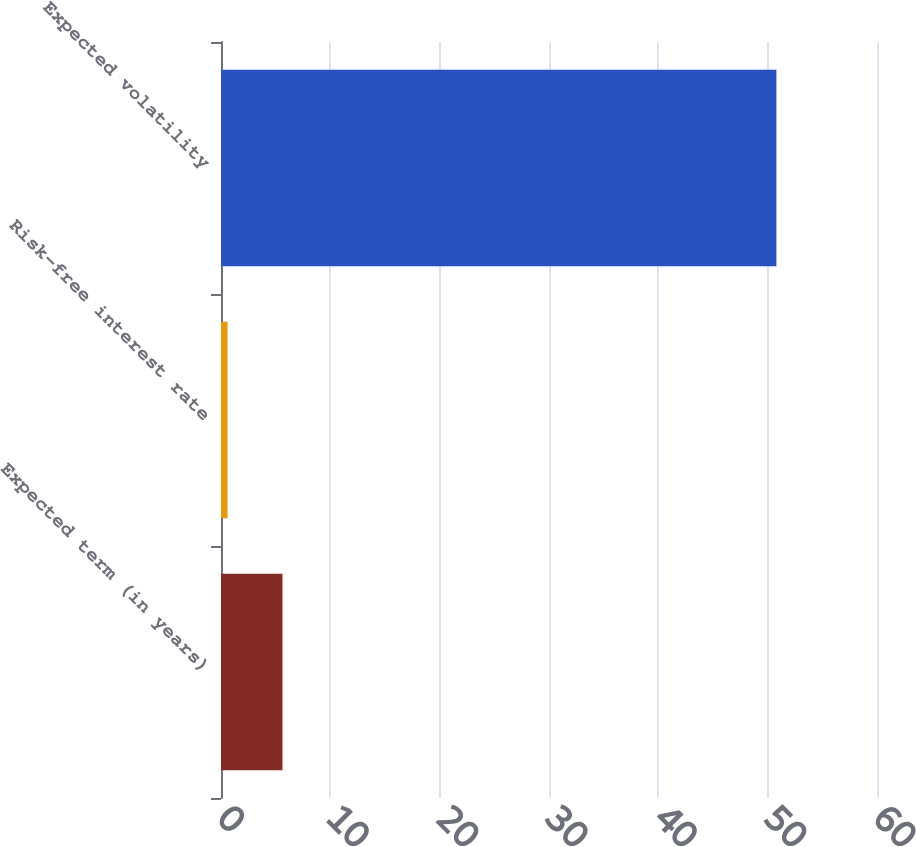<chart> <loc_0><loc_0><loc_500><loc_500><bar_chart><fcel>Expected term (in years)<fcel>Risk-free interest rate<fcel>Expected volatility<nl><fcel>5.62<fcel>0.6<fcel>50.8<nl></chart> 